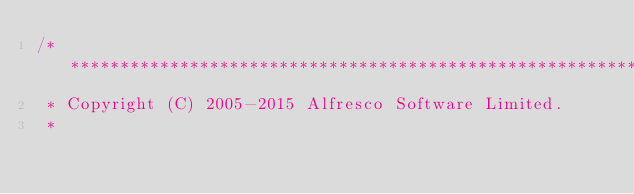<code> <loc_0><loc_0><loc_500><loc_500><_C_>/*******************************************************************************
 * Copyright (C) 2005-2015 Alfresco Software Limited.
 *</code> 